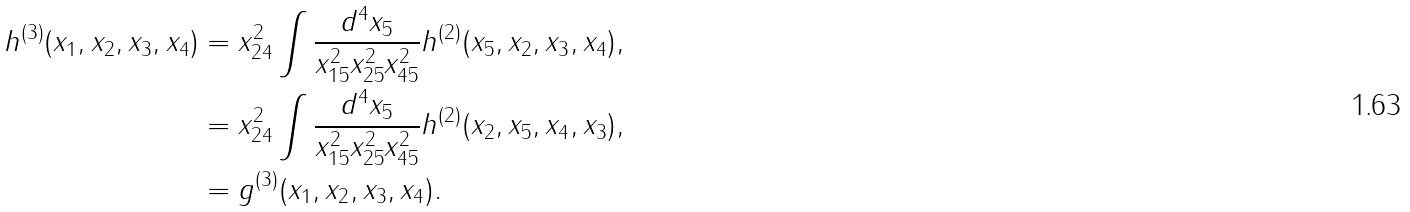<formula> <loc_0><loc_0><loc_500><loc_500>h ^ { ( 3 ) } ( x _ { 1 } , x _ { 2 } , x _ { 3 } , x _ { 4 } ) & = x _ { 2 4 } ^ { 2 } \int \frac { d ^ { 4 } x _ { 5 } } { x _ { 1 5 } ^ { 2 } x _ { 2 5 } ^ { 2 } x _ { 4 5 } ^ { 2 } } h ^ { ( 2 ) } ( x _ { 5 } , x _ { 2 } , x _ { 3 } , x _ { 4 } ) , \\ & = x _ { 2 4 } ^ { 2 } \int \frac { d ^ { 4 } x _ { 5 } } { x _ { 1 5 } ^ { 2 } x _ { 2 5 } ^ { 2 } x _ { 4 5 } ^ { 2 } } h ^ { ( 2 ) } ( x _ { 2 } , x _ { 5 } , x _ { 4 } , x _ { 3 } ) , \\ & = g ^ { ( 3 ) } ( x _ { 1 } , x _ { 2 } , x _ { 3 } , x _ { 4 } ) .</formula> 